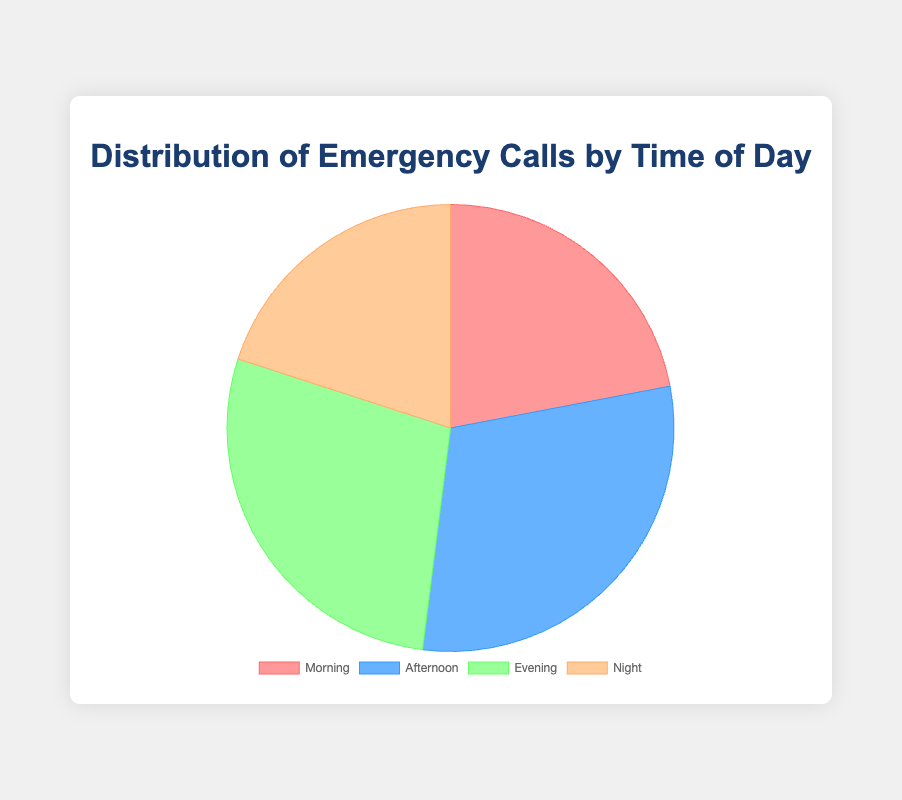What's the most common time of day for emergency calls? The pie chart shows the distribution of emergency calls across different times of day. The 'Afternoon' segment appears to be the largest, meaning it has the highest number of calls.
Answer: Afternoon How many more calls are there in the Afternoon compared to the Morning? The chart shows that Afternoon has 300 calls and Morning has 220 calls. The difference is 300 - 220.
Answer: 80 Which time of day has the least number of emergency calls? By observing the pie chart, the smallest segment corresponds to Night. Therefore, Night has the fewest calls.
Answer: Night What is the combined total of calls during Morning and Night? According to the chart, Morning has 220 calls and Night has 200 calls. Adding them together, 220 + 200.
Answer: 420 How does the number of emergency calls in the Evening compare to the Afternoon? The chart shows that Evening has 280 calls and Afternoon has 300 calls. Since 300 is greater than 280, there are fewer calls in the Evening compared to the Afternoon.
Answer: Evening has fewer than Afternoon What percentage of total emergency calls does the Evening represent? The total number of calls is 220 (Morning) + 300 (Afternoon) + 280 (Evening) + 200 (Night) = 1000. The percentage of calls in the Evening is (280 / 1000) * 100.
Answer: 28% Is there a greater difference in the number of calls between Morning and Afternoon or between Afternoon and Evening? Between Morning and Afternoon, the difference is 300 - 220 = 80. Between Afternoon and Evening, the difference is 300 - 280 = 20. The difference between Morning and Afternoon is greater.
Answer: Morning and Afternoon If you were to rank the times of day from most to least emergency calls, what would the order be? Based on the chart segments, rank the times from largest to smallest: Afternoon (300), Evening (280), Morning (220), Night (200).
Answer: Afternoon, Evening, Morning, Night 